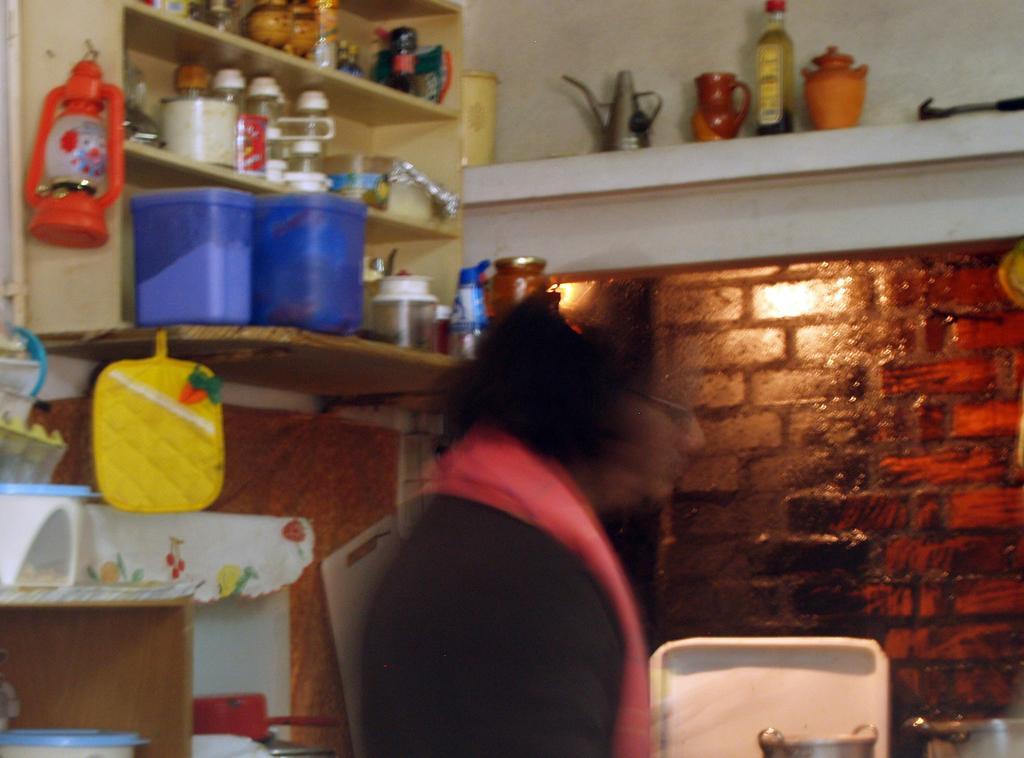Could you give a brief overview of what you see in this image? In this picture I can observe a woman in the middle of the picture. On the left side I can observe a shelf in which few things are placed. In the background I can observe a wall. 